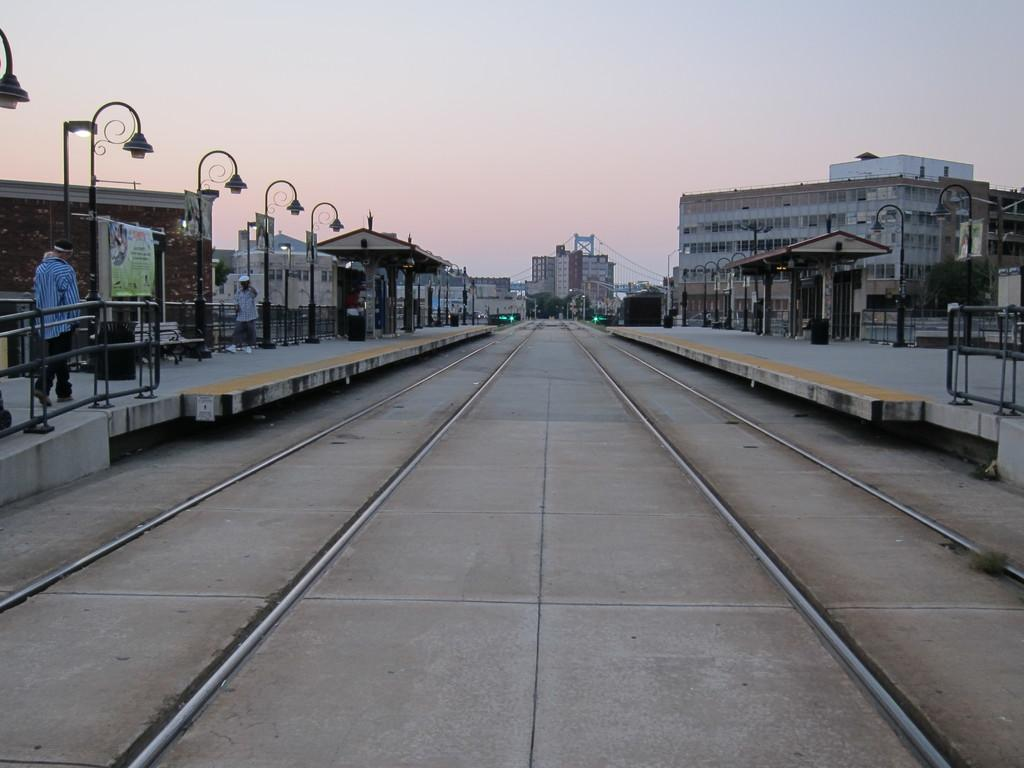What is the main feature of the image? There is a railway track in the image. Where are the people located in the image? The people are on the left side of the image. What type of structures can be seen on both sides of the image? There are buildings on the left and right sides of the image. What is visible at the top of the image? The sky is visible at the top of the image. Can you tell me how many zebras are in the prison depicted in the image? There are no zebras or prison present in the image; it features a railway track, people, buildings, and the sky. How many times do the people sneeze in the image? There is no indication of anyone sneezing in the image. 